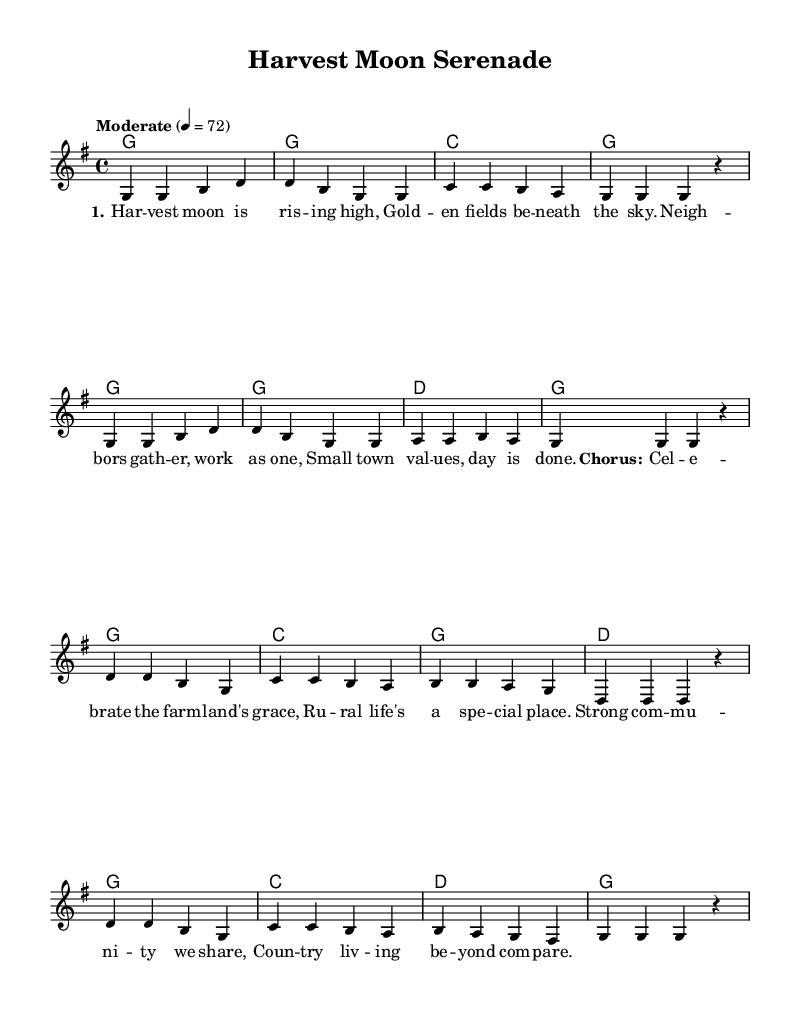What is the key signature of this music? The key signature is G major, which has one sharp (F#). This can be identified by looking at the key signature indicated at the beginning of the sheet music.
Answer: G major What is the time signature of this piece? The time signature is 4/4, which means there are four beats in each measure and a quarter note gets one beat. This is directly shown in the music notation at the beginning.
Answer: 4/4 What is the tempo marking for this composition? The tempo marking is "Moderate" with a beat of 72. This indicates a moderate speed for the piece and is noted in the tempo indication at the start of the music.
Answer: Moderate 4 = 72 How many measures are in the melody part? There are eight measures in the melody part. This can be determined by counting the vertical lines that separate the measures in the staff.
Answer: 8 Which chord is played in the first measure? The chord in the first measure is G major. This is evident from the chord names indicated above the staff at the beginning of the sheet music.
Answer: G major What are the themes celebrated in the lyrics? The themes celebrated in the lyrics are rural life and community values. This can be inferred from phrases within the lyrics that highlight the beauty of farm life and strong community ties.
Answer: Rural life and community values What type of music structure is primarily used in this ballad? The primary structure used in this ballad is verse and chorus. This is evident from the layout of the lyrics, where distinct sections are labeled as verses and a chorus.
Answer: Verse and chorus 